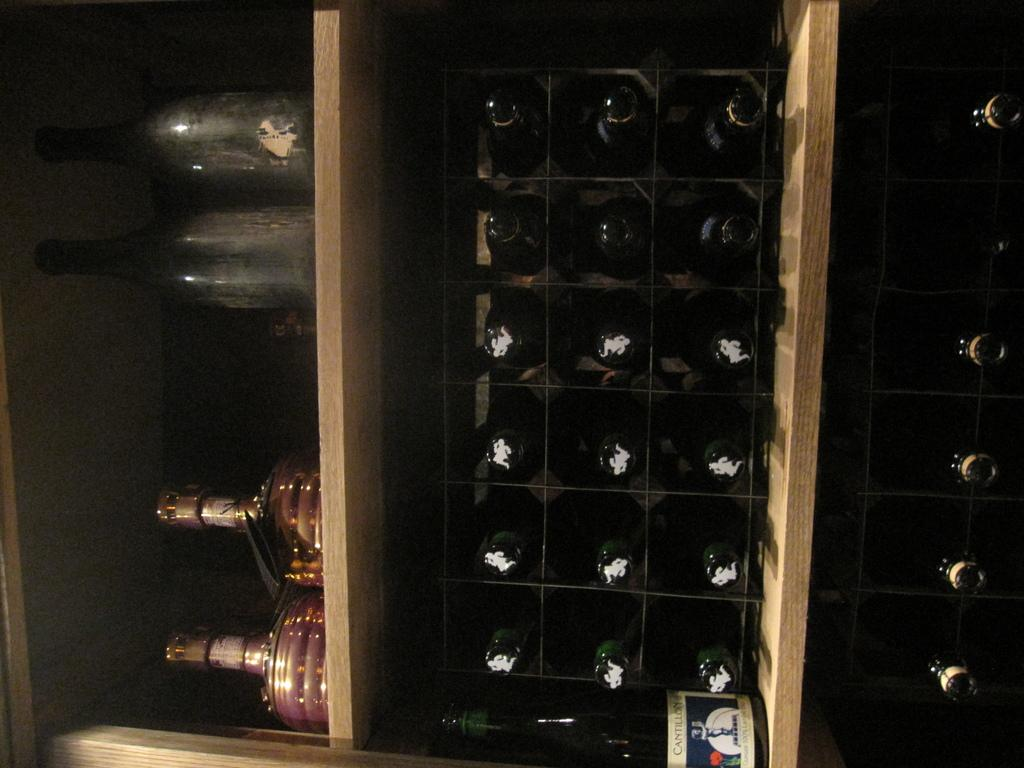What type of bottles are present in the image? There are wine bottles in the image. How are the wine bottles arranged or stored in the image? The wine bottles are kept in wooden racks. What type of crime is being committed in the image? There is no crime present in the image; it simply shows wine bottles stored in wooden racks. What kind of noise can be heard coming from the wine bottles in the image? Wine bottles do not make noise, so there is no noise to be heard from them in the image. 